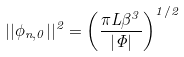Convert formula to latex. <formula><loc_0><loc_0><loc_500><loc_500>| | \phi _ { n , 0 } | | ^ { 2 } = \left ( \frac { \pi L \beta ^ { 3 } } { | \Phi | } \right ) ^ { 1 / 2 }</formula> 